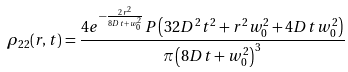Convert formula to latex. <formula><loc_0><loc_0><loc_500><loc_500>\rho _ { 2 2 } ( r , t ) = \frac { 4 e ^ { - \frac { 2 r ^ { 2 } } { 8 D t + w ^ { 2 } _ { 0 } } } P \left ( 3 2 D ^ { 2 } t ^ { 2 } + r ^ { 2 } w ^ { 2 } _ { 0 } + 4 D t w ^ { 2 } _ { 0 } \right ) } { \pi \left ( 8 D t + w ^ { 2 } _ { 0 } \right ) ^ { 3 } }</formula> 